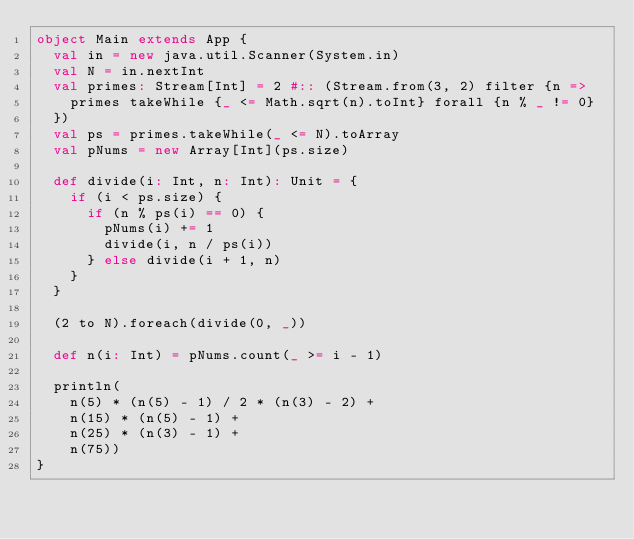<code> <loc_0><loc_0><loc_500><loc_500><_Scala_>object Main extends App {
  val in = new java.util.Scanner(System.in)
  val N = in.nextInt
  val primes: Stream[Int] = 2 #:: (Stream.from(3, 2) filter {n =>
    primes takeWhile {_ <= Math.sqrt(n).toInt} forall {n % _ != 0}
  })
  val ps = primes.takeWhile(_ <= N).toArray
  val pNums = new Array[Int](ps.size)

  def divide(i: Int, n: Int): Unit = {
    if (i < ps.size) {
      if (n % ps(i) == 0) {
        pNums(i) += 1
        divide(i, n / ps(i))
      } else divide(i + 1, n)
    }
  }

  (2 to N).foreach(divide(0, _))

  def n(i: Int) = pNums.count(_ >= i - 1)

  println(
    n(5) * (n(5) - 1) / 2 * (n(3) - 2) +
    n(15) * (n(5) - 1) +
    n(25) * (n(3) - 1) +
    n(75))
}</code> 